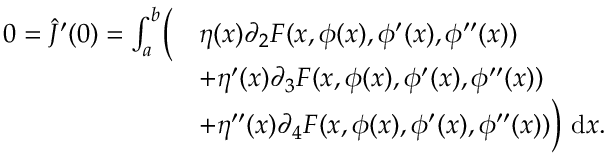Convert formula to latex. <formula><loc_0><loc_0><loc_500><loc_500>\begin{array} { r l } { 0 = \hat { J } ^ { \prime } ( 0 ) = \int _ { a } ^ { b } \left ( } & { \eta ( x ) \partial _ { 2 } F ( x , \phi ( x ) , \phi ^ { \prime } ( x ) , \phi ^ { \prime \prime } ( x ) ) } \\ & { + \eta ^ { \prime } ( x ) \partial _ { 3 } F ( x , \phi ( x ) , \phi ^ { \prime } ( x ) , \phi ^ { \prime \prime } ( x ) ) } \\ & { + \eta ^ { \prime \prime } ( x ) \partial _ { 4 } F ( x , \phi ( x ) , \phi ^ { \prime } ( x ) , \phi ^ { \prime \prime } ( x ) ) \right ) d x . } \end{array}</formula> 